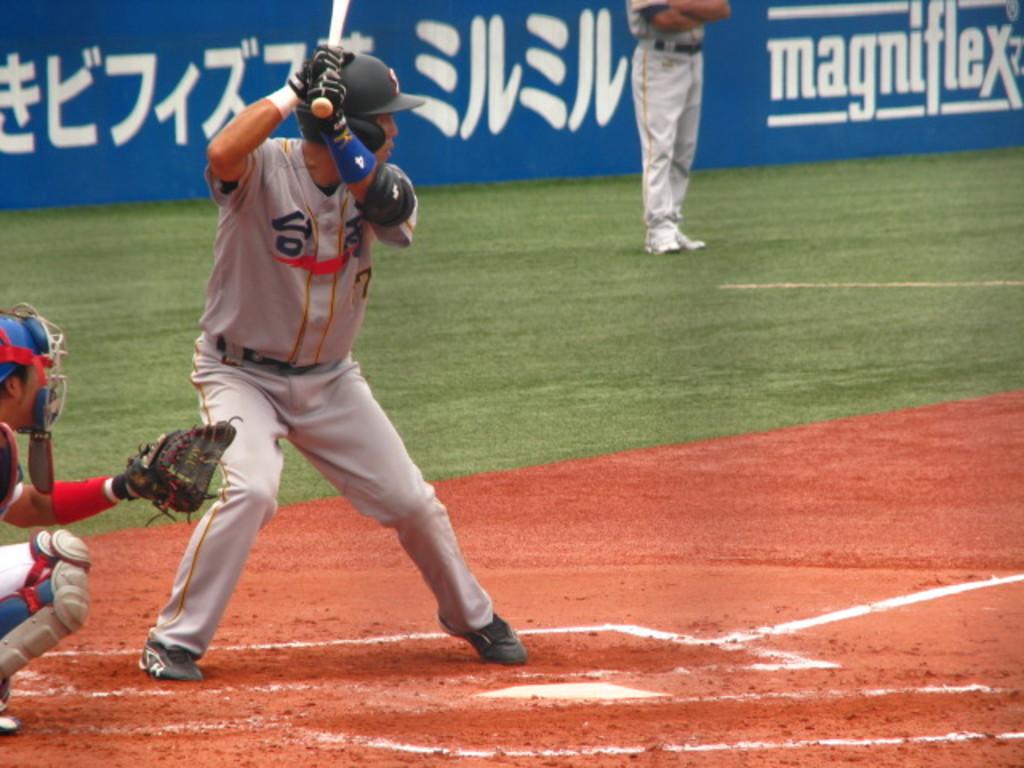What is the batters's number?
Keep it short and to the point. 7. What is the ad behind the hitter?
Your answer should be compact. Magniflex. 